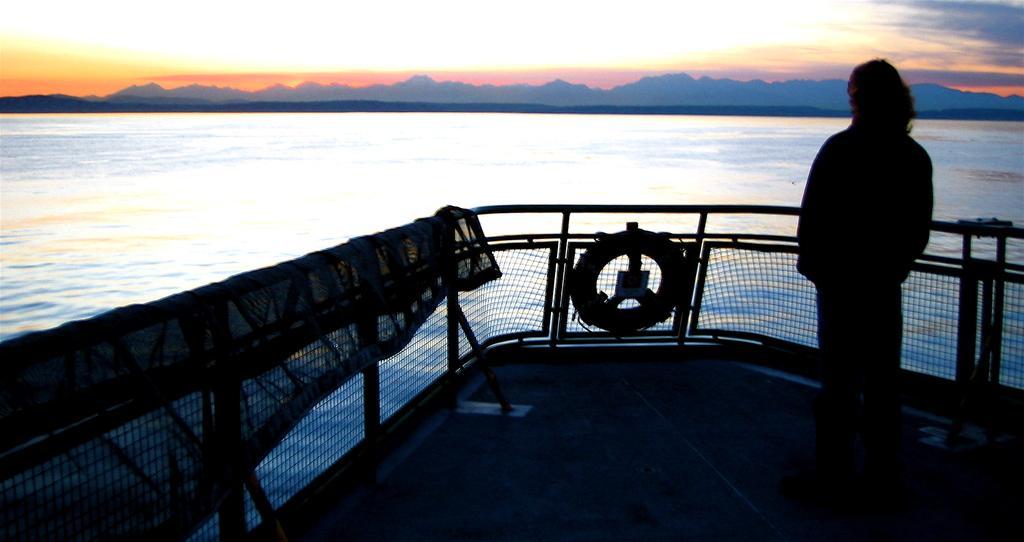Could you give a brief overview of what you see in this image? In this image at the bottom there is one boat, in that boat there is one person who is standing and there is one air balloon and a cloth. And in the background there is a river and some mountains. 